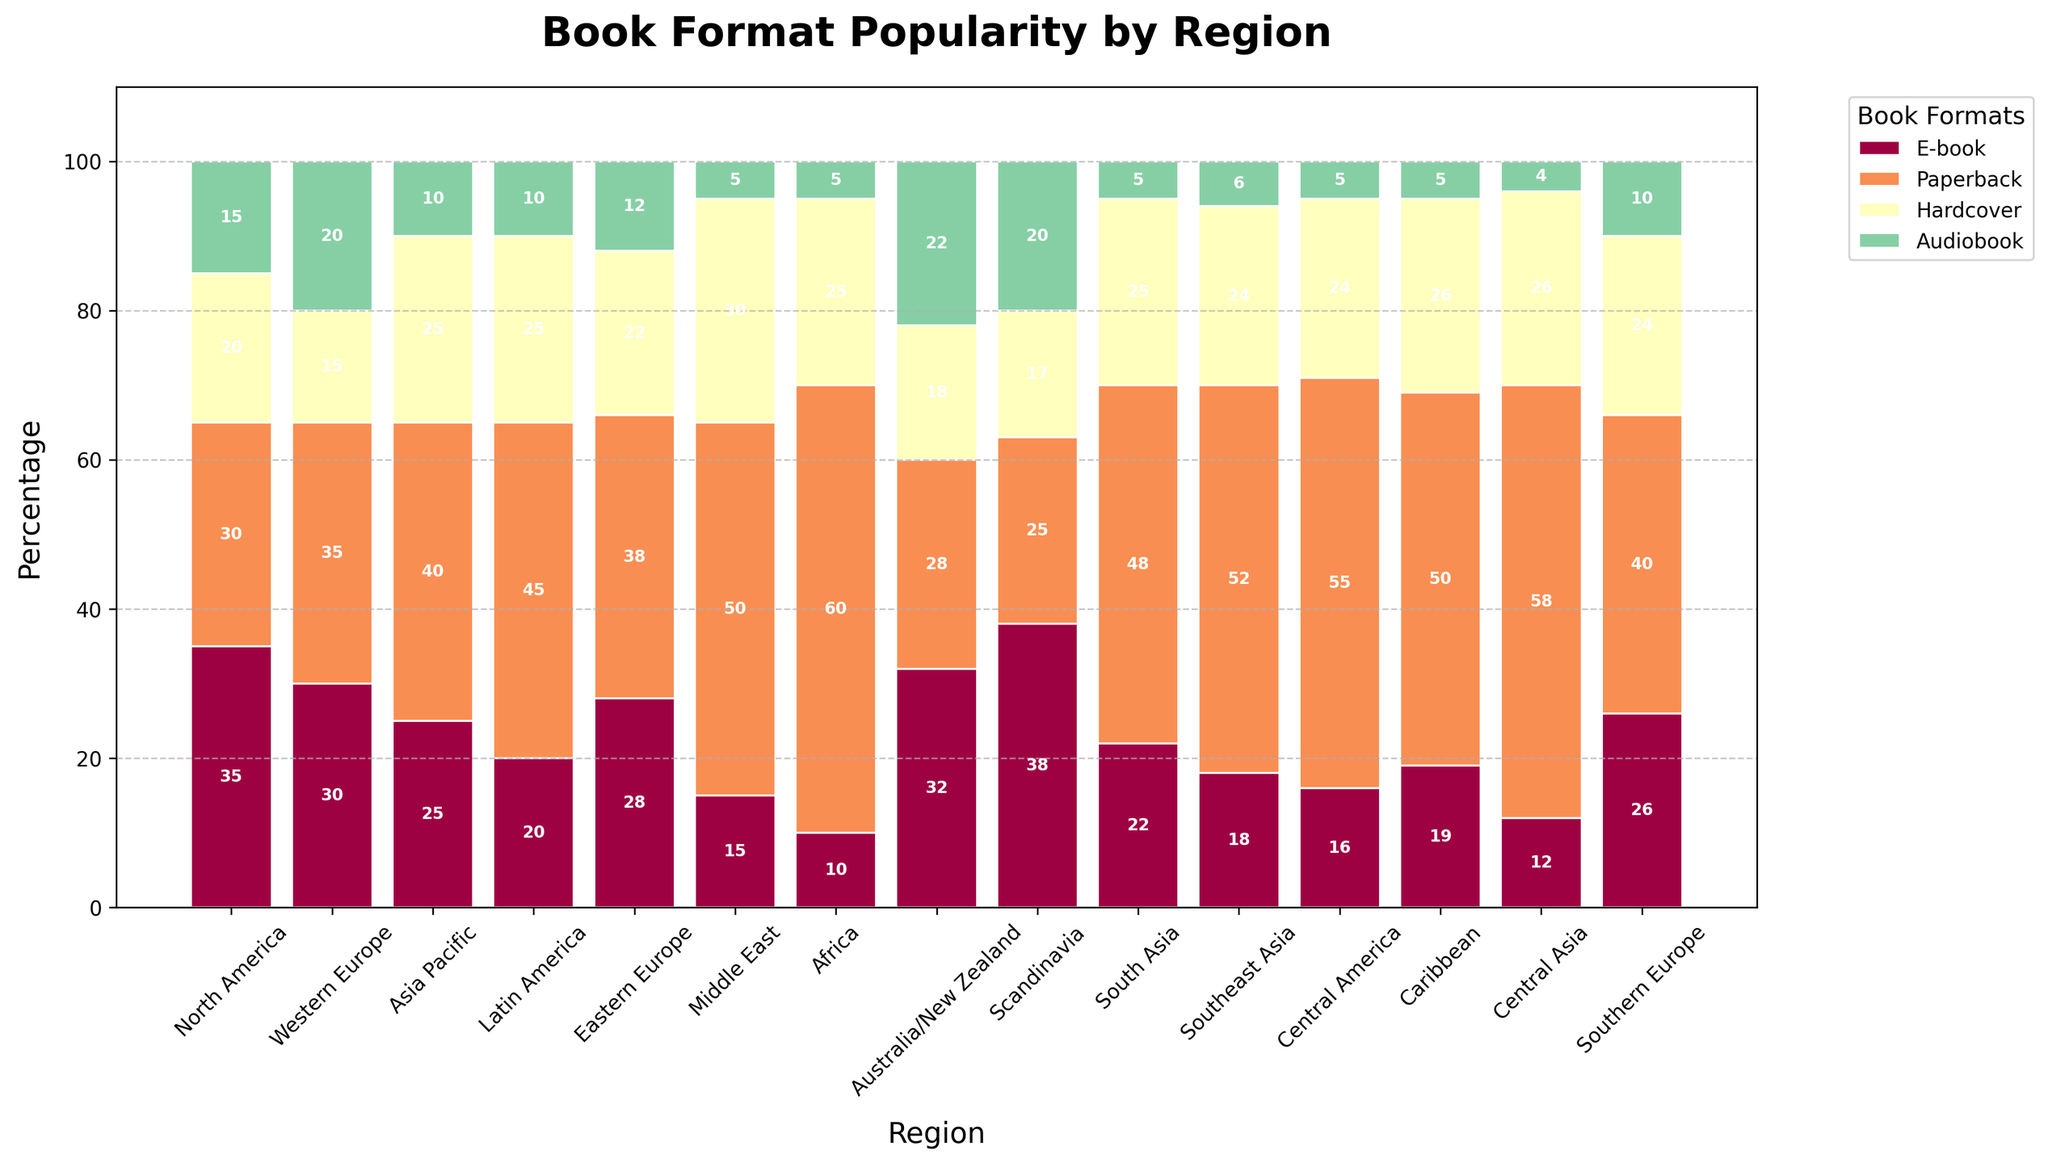Which region has the highest preference for audiobooks? By visually inspecting the height of the bars representing audiobooks across different regions, we see that Australia/New Zealand has the tallest bar, indicating the highest preference for audiobooks.
Answer: Australia/New Zealand Which book format has the highest average popularity across all regions? To determine the highest average popularity, sum the percentages of each format across all regions and divide by the number of regions. The format with the highest total will have the highest average. E-book: 378/15 = 25.2, Paperback: 656/15 = 43.73, Hardcover: 366/15 = 24.4, Audiobook: 144/15 = 9.6. Paperback has the highest average.
Answer: Paperback What is the total percentage of hardcover books in Western Europe and Southern Europe combined? Look at the height of the bars representing hardcover books for Western Europe (15%) and Southern Europe (24%), and sum these values: 15% + 24% = 39%.
Answer: 39% Which region has the least preference for e-books? By inspecting the height of the bars representing e-books across different regions, Africa has the shortest bar indicating the least preference for e-books.
Answer: Africa How does the preference for paperbacks in Latin America compare to that in North America? Compare the height of the bars representing paperbacks for both regions. Latin America has 45% while North America has 30%, so Latin America has a higher preference for paperbacks than North America.
Answer: Latin America What is the combined percentage of audiobook preference in Middle East and Southeast Asia? Look at the bars for audiobooks in Middle East (5%) and Southeast Asia (6%), then sum these values: 5% + 6% = 11%.
Answer: 11% In which region is the preference for hardcovers closest to 25%? Inspect the height of the bars representing hardcovers. Hardcovers in Asia Pacific (25%), Latin America (25%), South Asia (25%), Southeast Asia (24%), and Caribbean (26%) are closest to 25%, with Asia Pacific, Latin America, and South Asia exactly at 25%.
Answer: Asia Pacific, Latin America, South Asia 